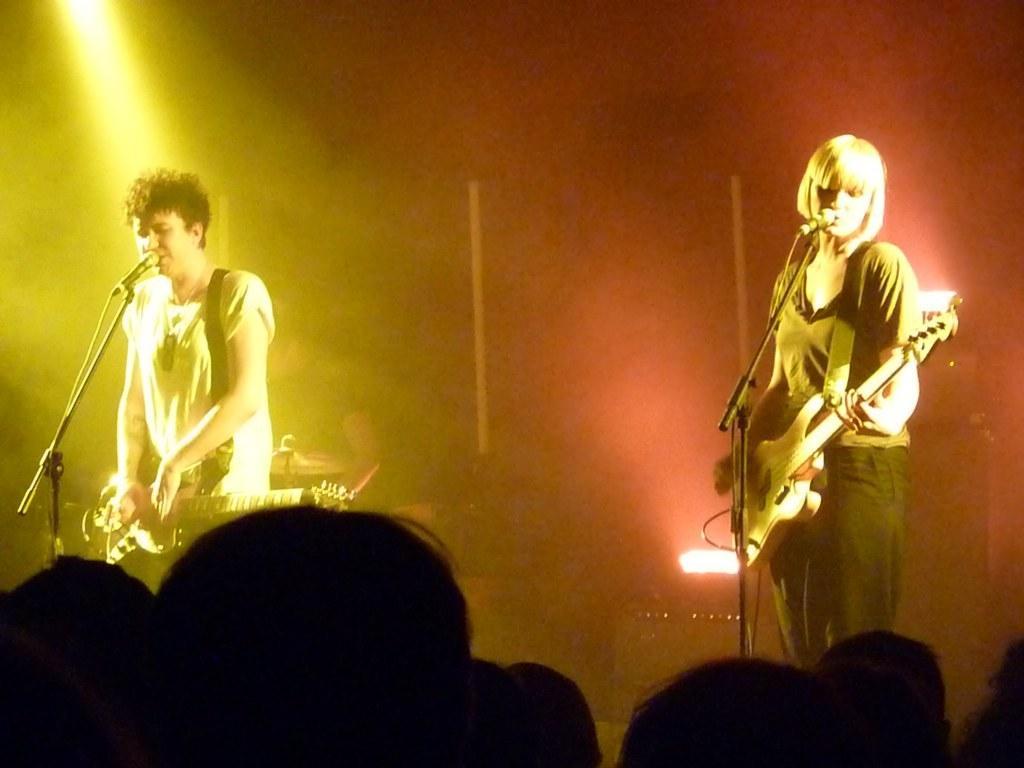How would you summarize this image in a sentence or two? It looks like a music show, there are two people standing on the stage, both of them are wearing guitars and playing music, in the background there is a yellow color light and red color light. 